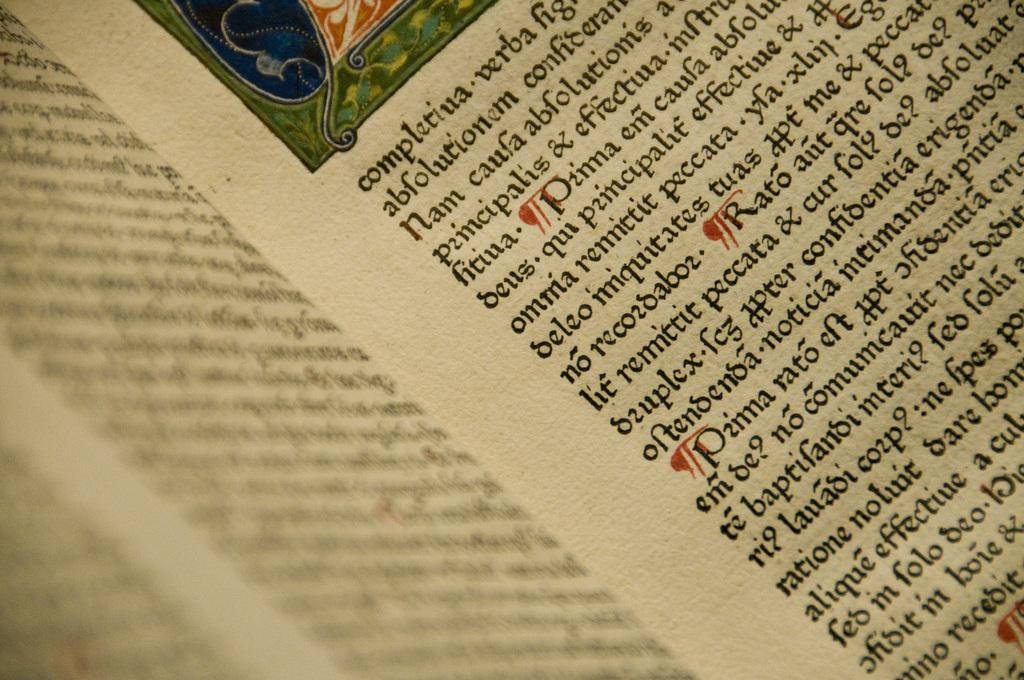<image>
Render a clear and concise summary of the photo. An open book with a paragraph starting with completiua. 